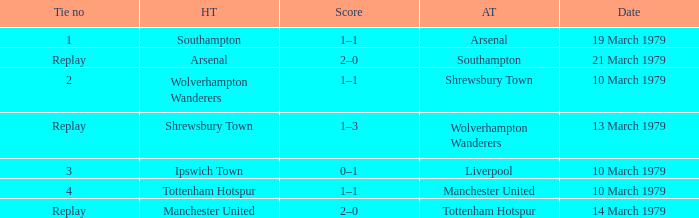What was the score of the tie that had Tottenham Hotspur as the home team? 1–1. 